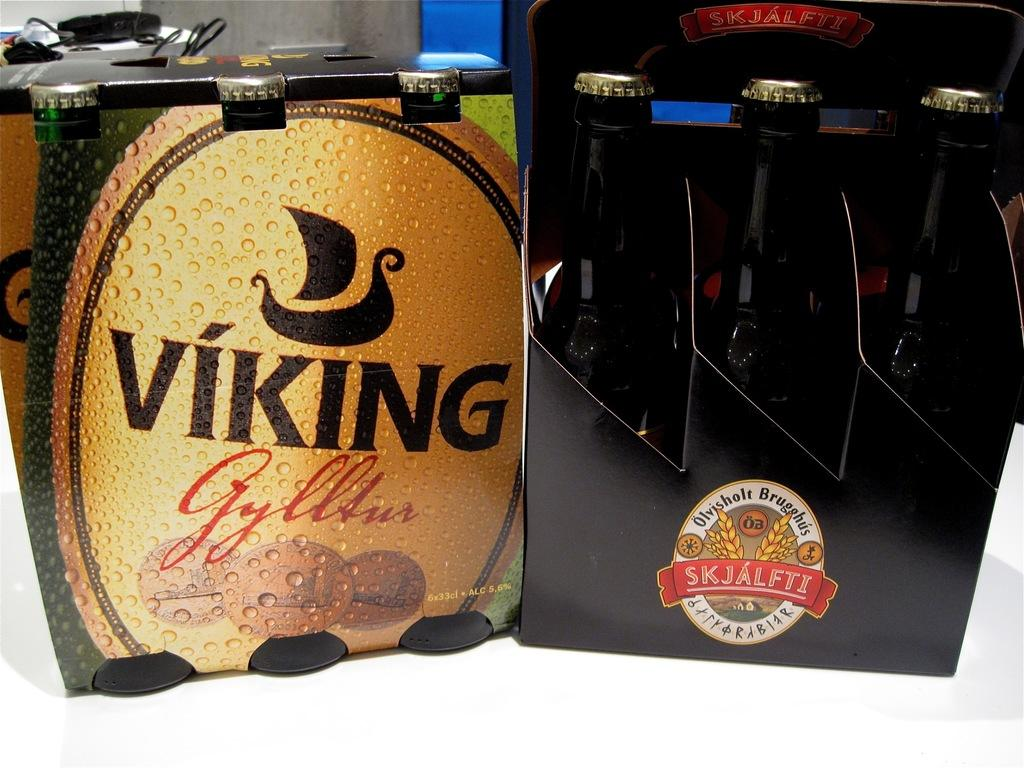What can be found inside the boxes in the image? The boxes contain bottles. Where are the boxes located in the image? The boxes are on a surface. What is visible at the top of the image? There is a wall and an object visible at the top of the image, as well as cables. What type of books are stacked on the boxes in the image? There are no books present in the image; it only shows boxes containing bottles. 